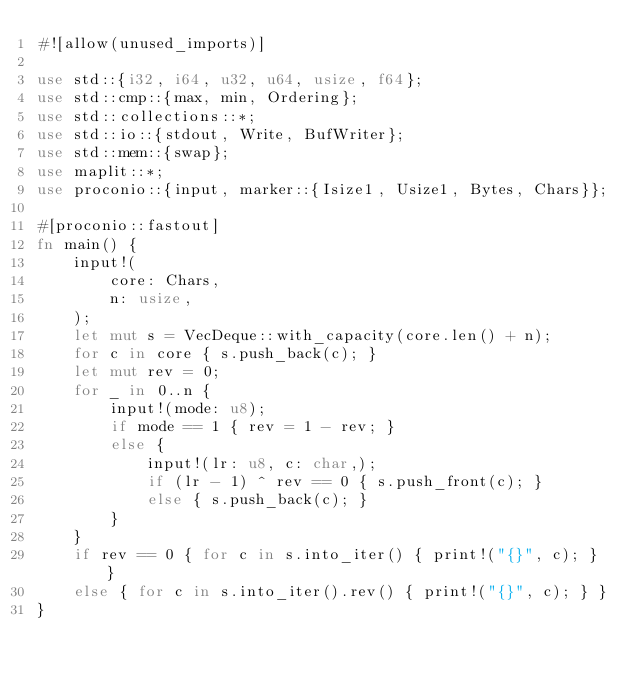Convert code to text. <code><loc_0><loc_0><loc_500><loc_500><_Rust_>#![allow(unused_imports)]

use std::{i32, i64, u32, u64, usize, f64};
use std::cmp::{max, min, Ordering};
use std::collections::*;
use std::io::{stdout, Write, BufWriter};
use std::mem::{swap};
use maplit::*;
use proconio::{input, marker::{Isize1, Usize1, Bytes, Chars}};

#[proconio::fastout]
fn main() {
    input!(
        core: Chars,
        n: usize,
    );
    let mut s = VecDeque::with_capacity(core.len() + n);
    for c in core { s.push_back(c); }
    let mut rev = 0;
    for _ in 0..n {
        input!(mode: u8);
        if mode == 1 { rev = 1 - rev; }
        else {
            input!(lr: u8, c: char,);
            if (lr - 1) ^ rev == 0 { s.push_front(c); }
            else { s.push_back(c); }
        }
    }
    if rev == 0 { for c in s.into_iter() { print!("{}", c); } }
    else { for c in s.into_iter().rev() { print!("{}", c); } }
}
</code> 